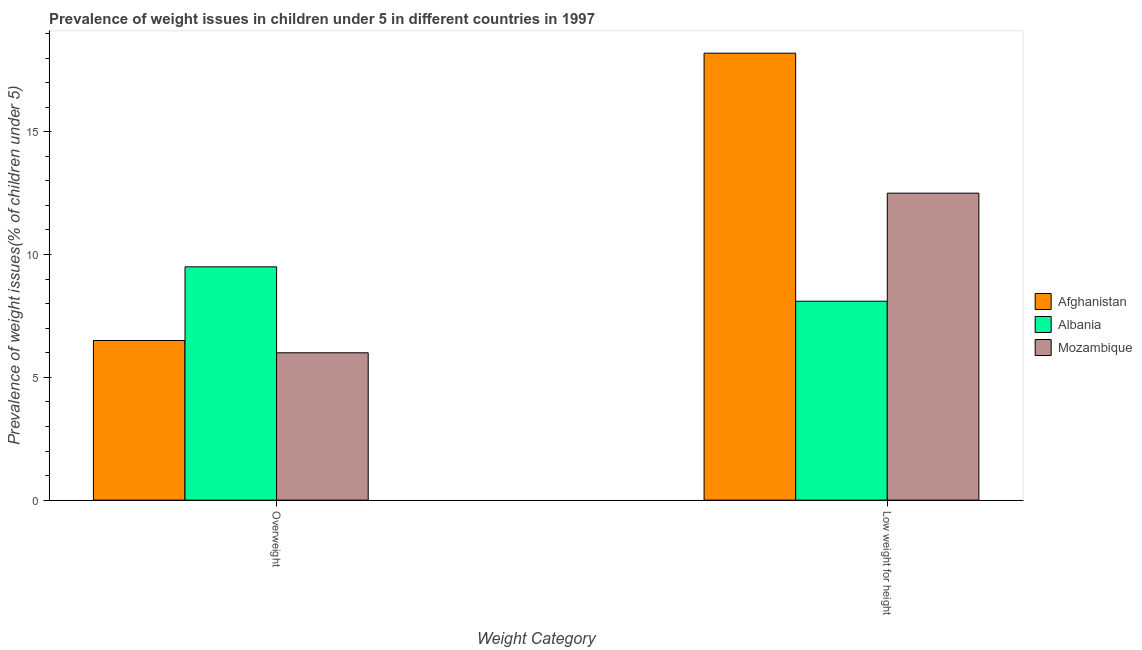How many different coloured bars are there?
Your response must be concise. 3. How many bars are there on the 2nd tick from the right?
Make the answer very short. 3. What is the label of the 1st group of bars from the left?
Give a very brief answer. Overweight. What is the percentage of underweight children in Afghanistan?
Ensure brevity in your answer.  18.2. Across all countries, what is the maximum percentage of underweight children?
Provide a succinct answer. 18.2. Across all countries, what is the minimum percentage of underweight children?
Provide a short and direct response. 8.1. In which country was the percentage of underweight children maximum?
Your response must be concise. Afghanistan. In which country was the percentage of underweight children minimum?
Keep it short and to the point. Albania. What is the difference between the percentage of underweight children in Mozambique and that in Albania?
Your answer should be very brief. 4.4. What is the difference between the percentage of underweight children in Albania and the percentage of overweight children in Mozambique?
Your response must be concise. 2.1. What is the average percentage of underweight children per country?
Your response must be concise. 12.93. What is the difference between the percentage of overweight children and percentage of underweight children in Afghanistan?
Your answer should be very brief. -11.7. What is the ratio of the percentage of overweight children in Afghanistan to that in Mozambique?
Your answer should be compact. 1.08. Is the percentage of underweight children in Albania less than that in Afghanistan?
Ensure brevity in your answer.  Yes. In how many countries, is the percentage of overweight children greater than the average percentage of overweight children taken over all countries?
Your response must be concise. 1. What does the 1st bar from the left in Low weight for height represents?
Your answer should be very brief. Afghanistan. What does the 2nd bar from the right in Overweight represents?
Make the answer very short. Albania. How many bars are there?
Ensure brevity in your answer.  6. Does the graph contain any zero values?
Provide a short and direct response. No. Where does the legend appear in the graph?
Give a very brief answer. Center right. How many legend labels are there?
Your answer should be compact. 3. What is the title of the graph?
Offer a very short reply. Prevalence of weight issues in children under 5 in different countries in 1997. What is the label or title of the X-axis?
Offer a terse response. Weight Category. What is the label or title of the Y-axis?
Keep it short and to the point. Prevalence of weight issues(% of children under 5). What is the Prevalence of weight issues(% of children under 5) of Afghanistan in Overweight?
Ensure brevity in your answer.  6.5. What is the Prevalence of weight issues(% of children under 5) of Afghanistan in Low weight for height?
Your answer should be very brief. 18.2. What is the Prevalence of weight issues(% of children under 5) of Albania in Low weight for height?
Give a very brief answer. 8.1. What is the Prevalence of weight issues(% of children under 5) of Mozambique in Low weight for height?
Provide a succinct answer. 12.5. Across all Weight Category, what is the maximum Prevalence of weight issues(% of children under 5) in Afghanistan?
Make the answer very short. 18.2. Across all Weight Category, what is the minimum Prevalence of weight issues(% of children under 5) in Afghanistan?
Give a very brief answer. 6.5. Across all Weight Category, what is the minimum Prevalence of weight issues(% of children under 5) of Albania?
Your response must be concise. 8.1. What is the total Prevalence of weight issues(% of children under 5) in Afghanistan in the graph?
Your answer should be very brief. 24.7. What is the total Prevalence of weight issues(% of children under 5) of Albania in the graph?
Your answer should be very brief. 17.6. What is the total Prevalence of weight issues(% of children under 5) of Mozambique in the graph?
Offer a terse response. 18.5. What is the difference between the Prevalence of weight issues(% of children under 5) of Albania in Overweight and that in Low weight for height?
Ensure brevity in your answer.  1.4. What is the difference between the Prevalence of weight issues(% of children under 5) in Mozambique in Overweight and that in Low weight for height?
Keep it short and to the point. -6.5. What is the difference between the Prevalence of weight issues(% of children under 5) in Afghanistan in Overweight and the Prevalence of weight issues(% of children under 5) in Albania in Low weight for height?
Offer a terse response. -1.6. What is the average Prevalence of weight issues(% of children under 5) in Afghanistan per Weight Category?
Your answer should be compact. 12.35. What is the average Prevalence of weight issues(% of children under 5) in Mozambique per Weight Category?
Your answer should be compact. 9.25. What is the difference between the Prevalence of weight issues(% of children under 5) in Afghanistan and Prevalence of weight issues(% of children under 5) in Albania in Overweight?
Your response must be concise. -3. What is the difference between the Prevalence of weight issues(% of children under 5) of Afghanistan and Prevalence of weight issues(% of children under 5) of Albania in Low weight for height?
Provide a short and direct response. 10.1. What is the ratio of the Prevalence of weight issues(% of children under 5) of Afghanistan in Overweight to that in Low weight for height?
Your answer should be very brief. 0.36. What is the ratio of the Prevalence of weight issues(% of children under 5) in Albania in Overweight to that in Low weight for height?
Offer a terse response. 1.17. What is the ratio of the Prevalence of weight issues(% of children under 5) of Mozambique in Overweight to that in Low weight for height?
Your response must be concise. 0.48. What is the difference between the highest and the second highest Prevalence of weight issues(% of children under 5) of Afghanistan?
Provide a succinct answer. 11.7. What is the difference between the highest and the second highest Prevalence of weight issues(% of children under 5) in Albania?
Offer a terse response. 1.4. What is the difference between the highest and the second highest Prevalence of weight issues(% of children under 5) in Mozambique?
Offer a terse response. 6.5. What is the difference between the highest and the lowest Prevalence of weight issues(% of children under 5) in Afghanistan?
Offer a very short reply. 11.7. What is the difference between the highest and the lowest Prevalence of weight issues(% of children under 5) in Albania?
Keep it short and to the point. 1.4. 